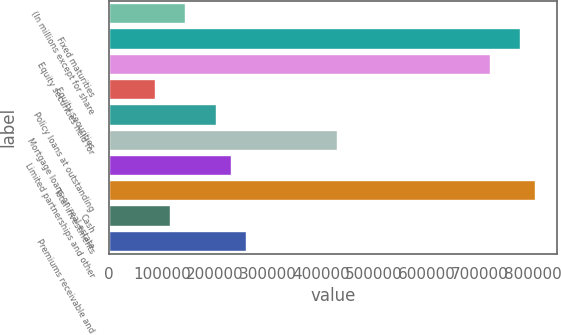<chart> <loc_0><loc_0><loc_500><loc_500><bar_chart><fcel>(In millions except for share<fcel>Fixed maturities<fcel>Equity securities held for<fcel>Equity securities<fcel>Policy loans at outstanding<fcel>Mortgage loans on real estate<fcel>Limited partnerships and other<fcel>Total investments<fcel>Cash<fcel>Premiums receivable and<nl><fcel>143793<fcel>776469<fcel>718953<fcel>86277<fcel>201309<fcel>431373<fcel>230067<fcel>805227<fcel>115035<fcel>258825<nl></chart> 